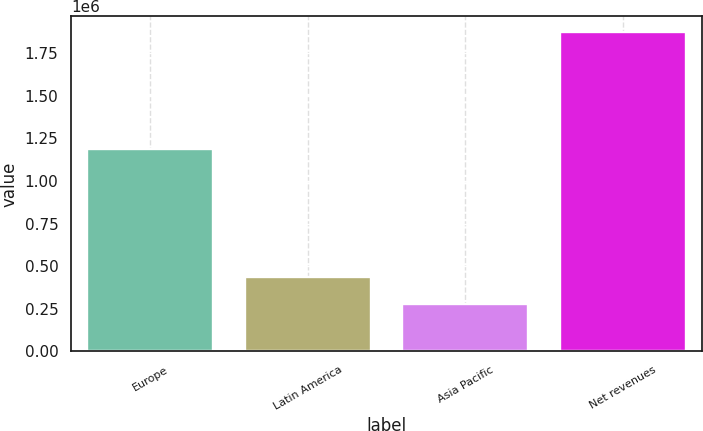Convert chart. <chart><loc_0><loc_0><loc_500><loc_500><bar_chart><fcel>Europe<fcel>Latin America<fcel>Asia Pacific<fcel>Net revenues<nl><fcel>1.19035e+06<fcel>434726<fcel>274920<fcel>1.87298e+06<nl></chart> 